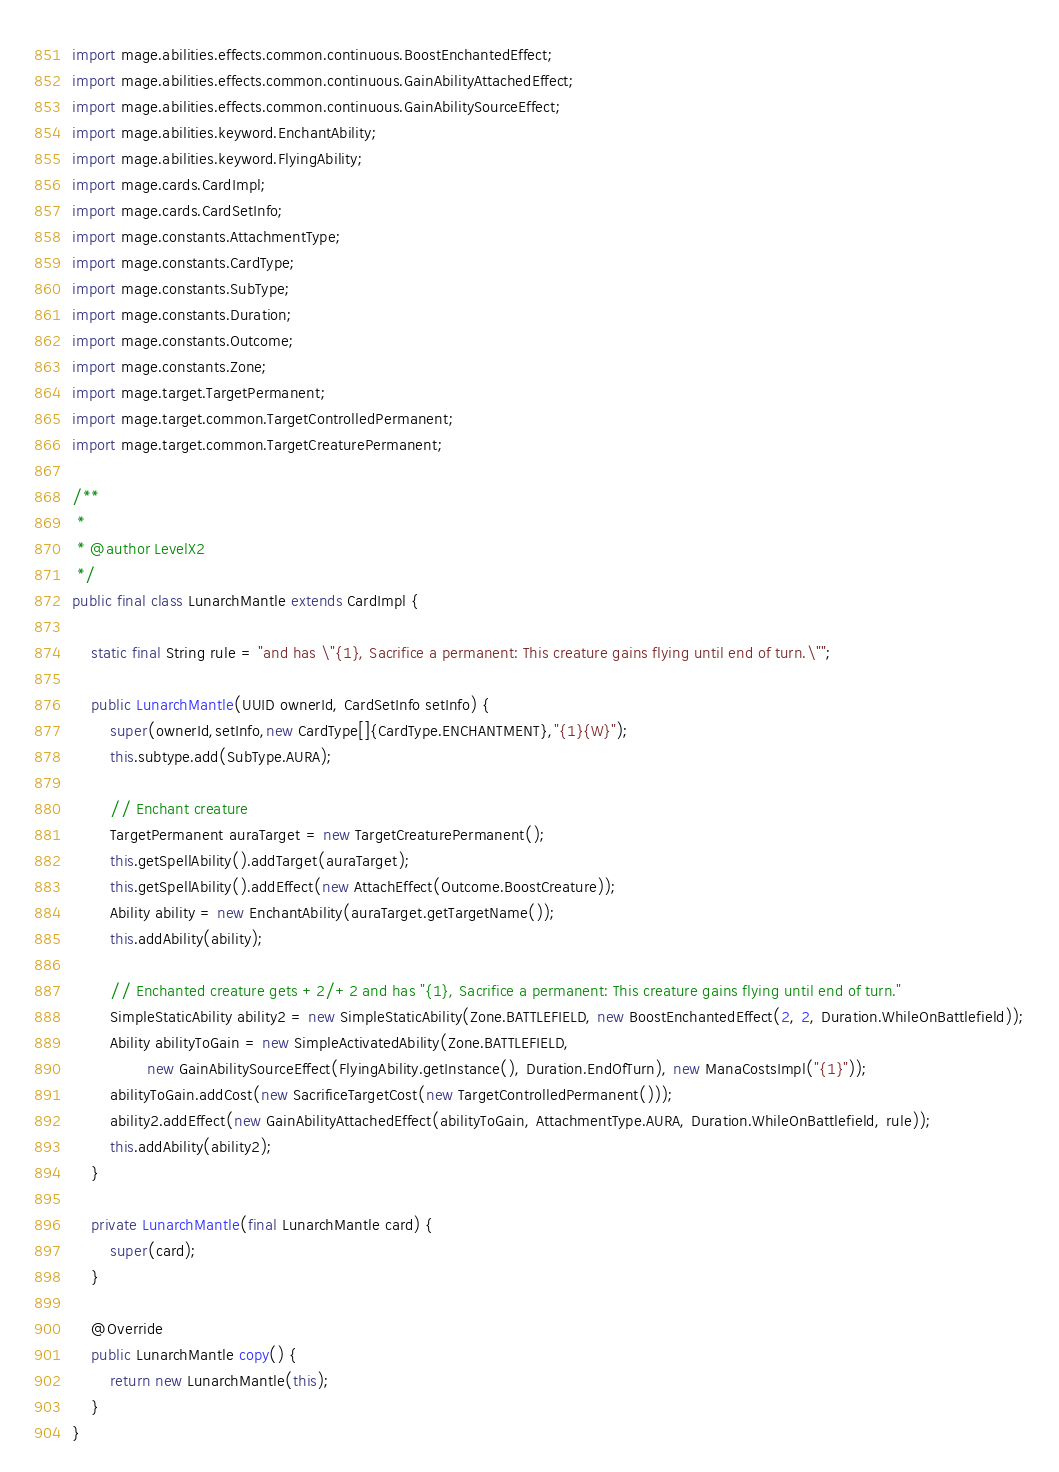<code> <loc_0><loc_0><loc_500><loc_500><_Java_>import mage.abilities.effects.common.continuous.BoostEnchantedEffect;
import mage.abilities.effects.common.continuous.GainAbilityAttachedEffect;
import mage.abilities.effects.common.continuous.GainAbilitySourceEffect;
import mage.abilities.keyword.EnchantAbility;
import mage.abilities.keyword.FlyingAbility;
import mage.cards.CardImpl;
import mage.cards.CardSetInfo;
import mage.constants.AttachmentType;
import mage.constants.CardType;
import mage.constants.SubType;
import mage.constants.Duration;
import mage.constants.Outcome;
import mage.constants.Zone;
import mage.target.TargetPermanent;
import mage.target.common.TargetControlledPermanent;
import mage.target.common.TargetCreaturePermanent;

/**
 *
 * @author LevelX2
 */
public final class LunarchMantle extends CardImpl {

    static final String rule = "and has \"{1}, Sacrifice a permanent: This creature gains flying until end of turn.\"";

    public LunarchMantle(UUID ownerId, CardSetInfo setInfo) {
        super(ownerId,setInfo,new CardType[]{CardType.ENCHANTMENT},"{1}{W}");
        this.subtype.add(SubType.AURA);

        // Enchant creature
        TargetPermanent auraTarget = new TargetCreaturePermanent();
        this.getSpellAbility().addTarget(auraTarget);
        this.getSpellAbility().addEffect(new AttachEffect(Outcome.BoostCreature));
        Ability ability = new EnchantAbility(auraTarget.getTargetName());
        this.addAbility(ability);

        // Enchanted creature gets +2/+2 and has "{1}, Sacrifice a permanent: This creature gains flying until end of turn."
        SimpleStaticAbility ability2 = new SimpleStaticAbility(Zone.BATTLEFIELD, new BoostEnchantedEffect(2, 2, Duration.WhileOnBattlefield));
        Ability abilityToGain = new SimpleActivatedAbility(Zone.BATTLEFIELD,
                new GainAbilitySourceEffect(FlyingAbility.getInstance(), Duration.EndOfTurn), new ManaCostsImpl("{1}"));
        abilityToGain.addCost(new SacrificeTargetCost(new TargetControlledPermanent()));
        ability2.addEffect(new GainAbilityAttachedEffect(abilityToGain, AttachmentType.AURA, Duration.WhileOnBattlefield, rule));
        this.addAbility(ability2);
    }

    private LunarchMantle(final LunarchMantle card) {
        super(card);
    }

    @Override
    public LunarchMantle copy() {
        return new LunarchMantle(this);
    }
}
</code> 